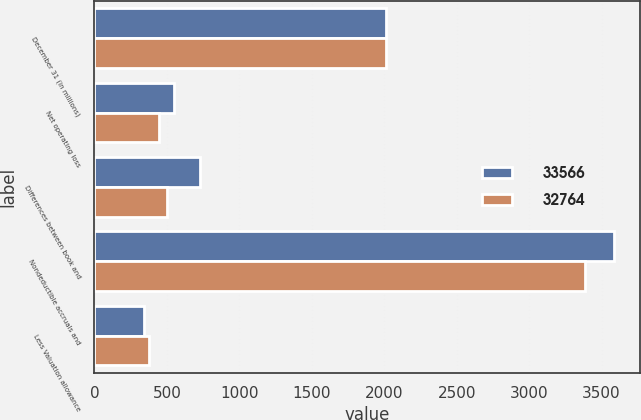<chart> <loc_0><loc_0><loc_500><loc_500><stacked_bar_chart><ecel><fcel>December 31 (in millions)<fcel>Net operating loss<fcel>Differences between book and<fcel>Nondeductible accruals and<fcel>Less Valuation allowance<nl><fcel>33566<fcel>2015<fcel>551<fcel>731<fcel>3589<fcel>342<nl><fcel>32764<fcel>2014<fcel>448<fcel>504<fcel>3383<fcel>375<nl></chart> 